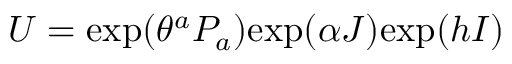<formula> <loc_0><loc_0><loc_500><loc_500>U = e x p ( \theta ^ { a } P _ { a } ) e x p ( \alpha J ) e x p ( h I )</formula> 